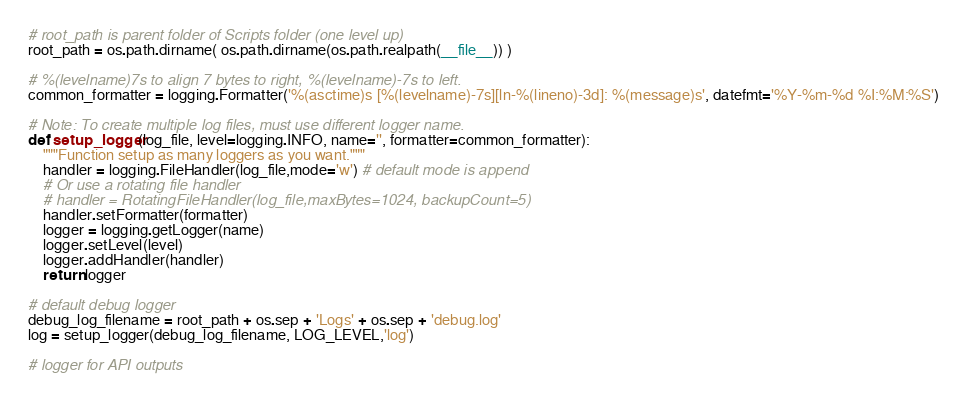Convert code to text. <code><loc_0><loc_0><loc_500><loc_500><_Python_># root_path is parent folder of Scripts folder (one level up)
root_path = os.path.dirname( os.path.dirname(os.path.realpath(__file__)) )

# %(levelname)7s to align 7 bytes to right, %(levelname)-7s to left.
common_formatter = logging.Formatter('%(asctime)s [%(levelname)-7s][ln-%(lineno)-3d]: %(message)s', datefmt='%Y-%m-%d %I:%M:%S')

# Note: To create multiple log files, must use different logger name.
def setup_logger(log_file, level=logging.INFO, name='', formatter=common_formatter):
    """Function setup as many loggers as you want."""
    handler = logging.FileHandler(log_file,mode='w') # default mode is append
    # Or use a rotating file handler
    # handler = RotatingFileHandler(log_file,maxBytes=1024, backupCount=5)          
    handler.setFormatter(formatter)    
    logger = logging.getLogger(name)
    logger.setLevel(level)
    logger.addHandler(handler)    
    return logger   
    
# default debug logger 
debug_log_filename = root_path + os.sep + 'Logs' + os.sep + 'debug.log'
log = setup_logger(debug_log_filename, LOG_LEVEL,'log')

# logger for API outputs</code> 